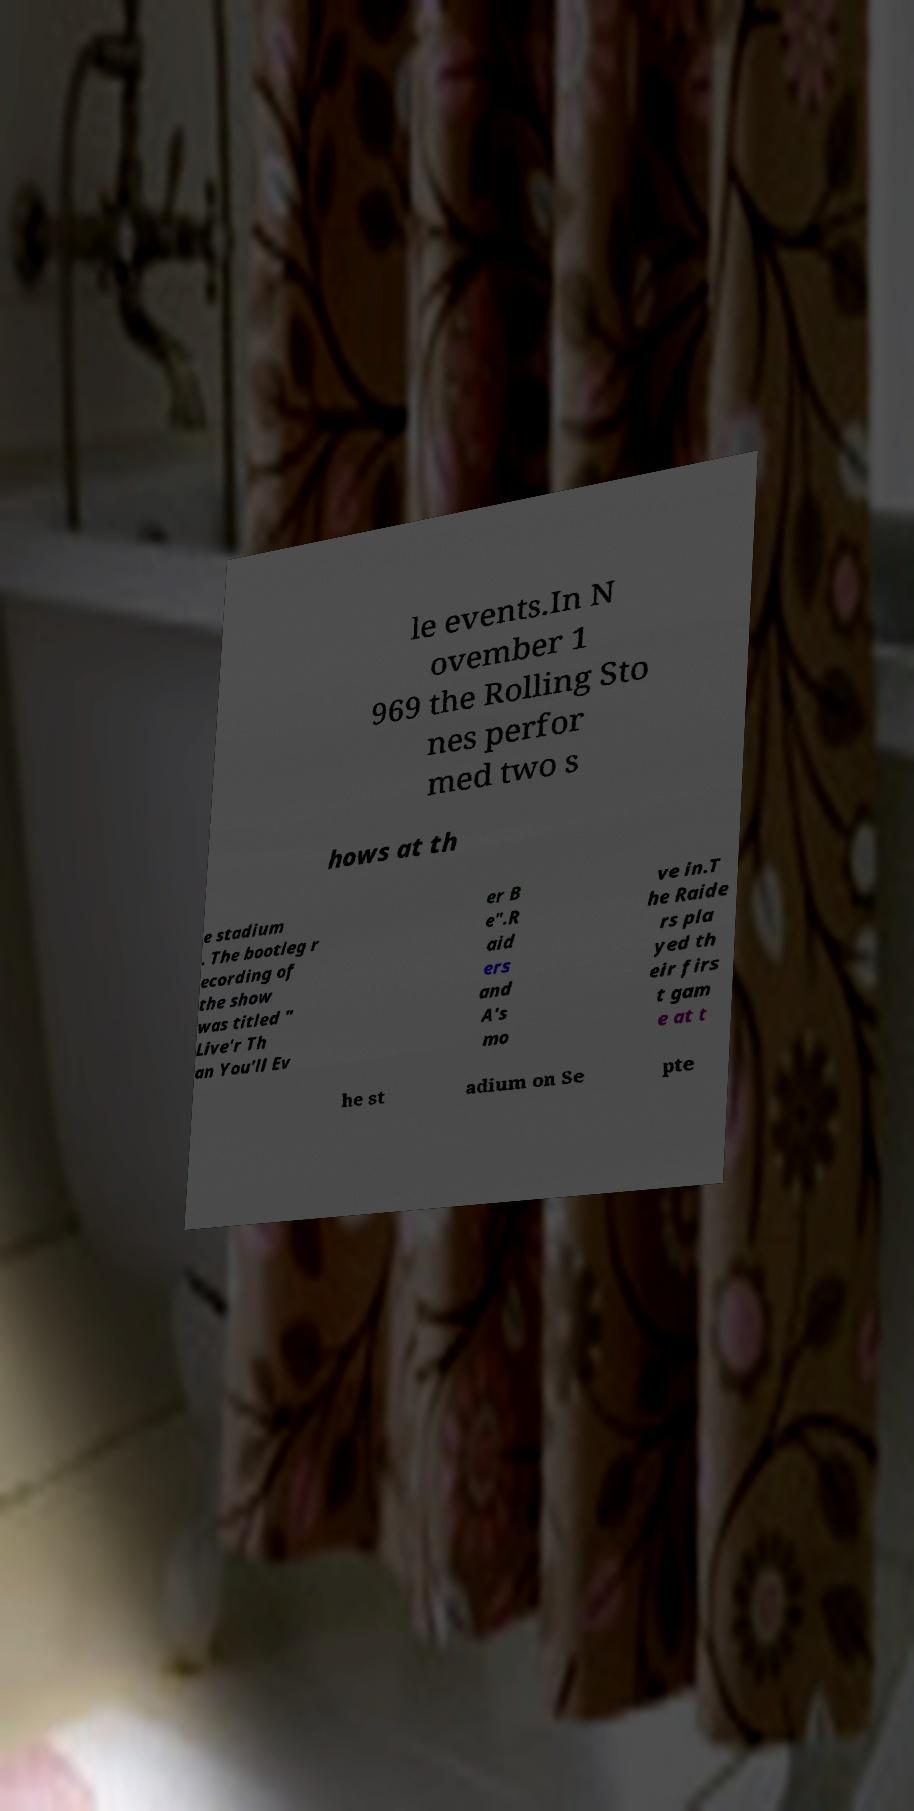Please identify and transcribe the text found in this image. le events.In N ovember 1 969 the Rolling Sto nes perfor med two s hows at th e stadium . The bootleg r ecording of the show was titled " Live'r Th an You'll Ev er B e".R aid ers and A's mo ve in.T he Raide rs pla yed th eir firs t gam e at t he st adium on Se pte 